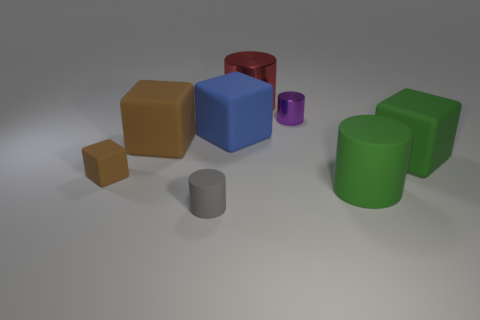Is the shape of the red thing the same as the gray thing that is in front of the small purple thing?
Ensure brevity in your answer.  Yes. Is there a green matte block in front of the object to the left of the big thing on the left side of the tiny gray matte cylinder?
Your answer should be very brief. No. The purple cylinder has what size?
Your answer should be very brief. Small. What number of other objects are the same color as the small cube?
Provide a succinct answer. 1. There is a brown rubber thing that is to the right of the tiny cube; is its shape the same as the big blue object?
Your answer should be compact. Yes. There is another small rubber object that is the same shape as the blue thing; what is its color?
Your answer should be very brief. Brown. Are there any other things that have the same material as the big red object?
Your answer should be very brief. Yes. There is a red shiny thing that is the same shape as the small purple thing; what is its size?
Offer a terse response. Large. There is a cylinder that is in front of the tiny purple cylinder and to the right of the blue cube; what material is it made of?
Ensure brevity in your answer.  Rubber. Does the tiny cylinder in front of the tiny metal object have the same color as the small metallic thing?
Your answer should be compact. No. 